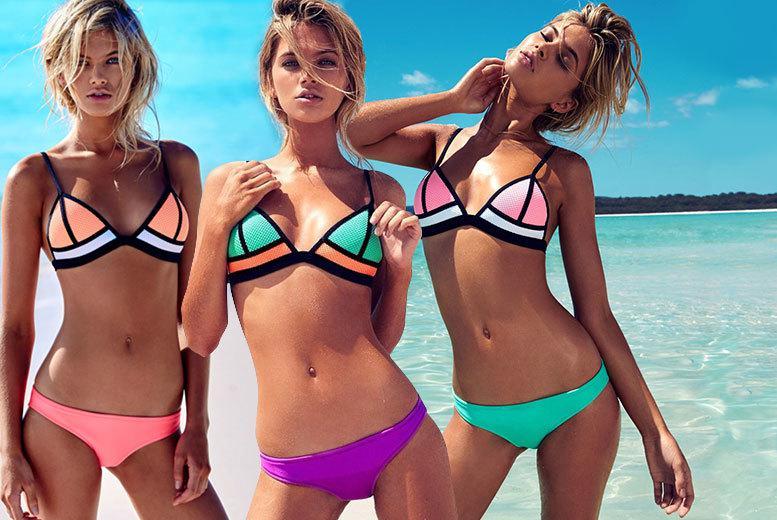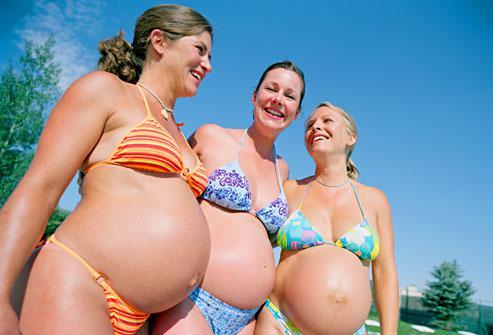The first image is the image on the left, the second image is the image on the right. Considering the images on both sides, is "Three models pose with rears turned to the camera in one image." valid? Answer yes or no. No. The first image is the image on the left, the second image is the image on the right. Assess this claim about the two images: "Three women have their backs at the camera.". Correct or not? Answer yes or no. No. 